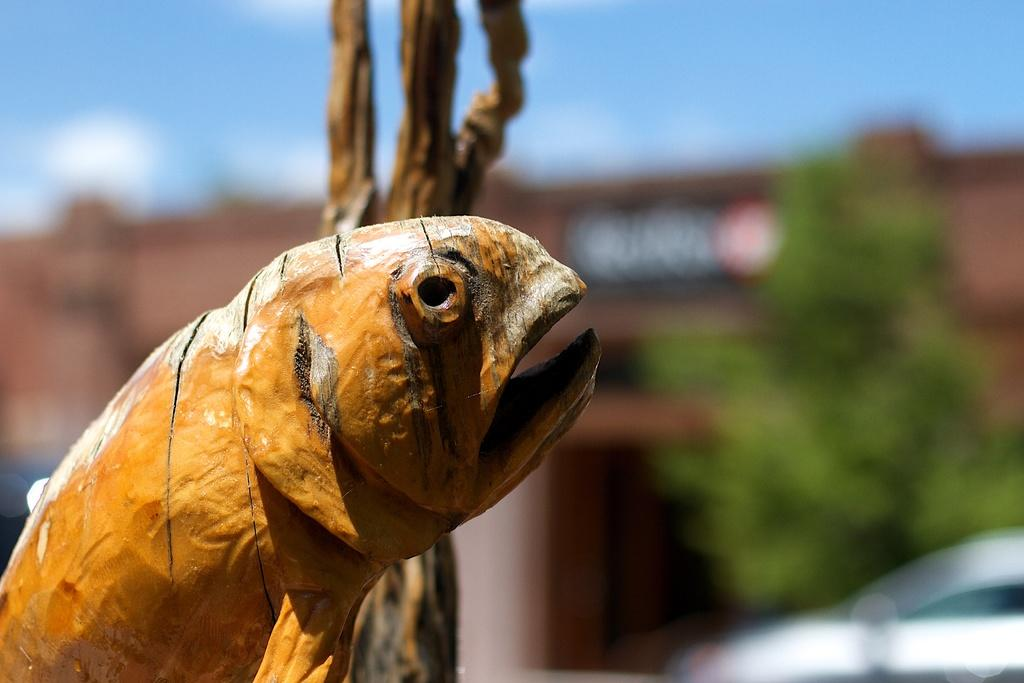What is the main subject in the center of the image? There is a fish made of wooden blocks in the center of the image. What else can be seen beside the main subject? There is an object beside the fish. Can you describe the background of the image? The background of the image is blurred. What type of plants can be seen growing in the background of the image? There are no plants visible in the background of the image; it is blurred. What hour of the day is depicted in the image? The image does not provide any information about the time of day, so it is not possible to determine the hour. 